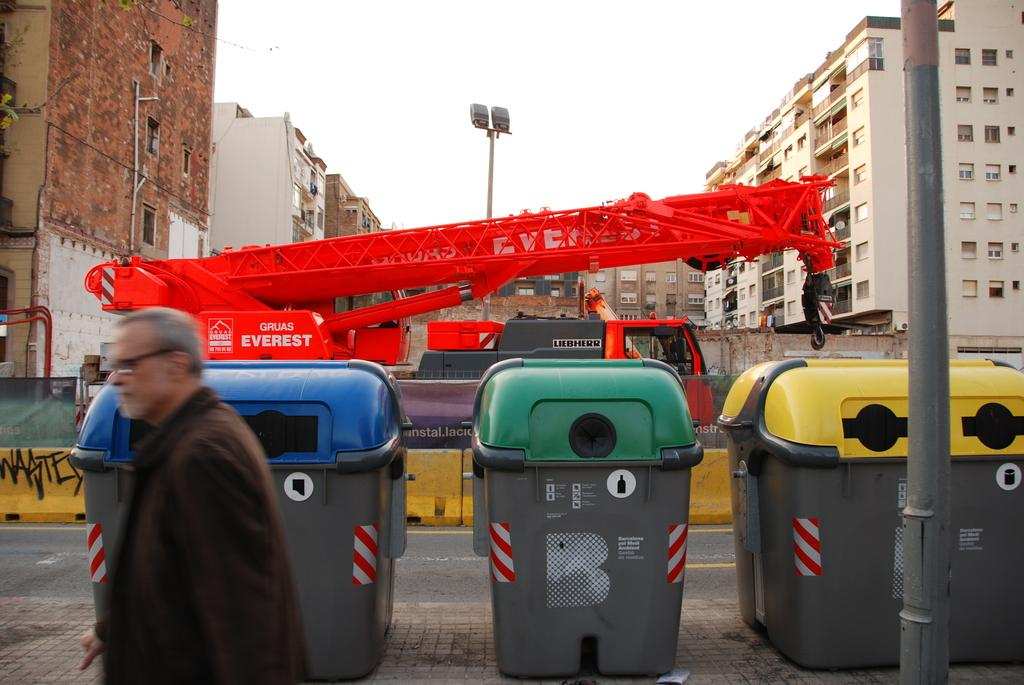<image>
Relay a brief, clear account of the picture shown. A man walks by trash cans and a crane saying Gruas Everest. 